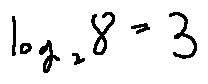Convert formula to latex. <formula><loc_0><loc_0><loc_500><loc_500>\log _ { 2 } 8 = 3</formula> 